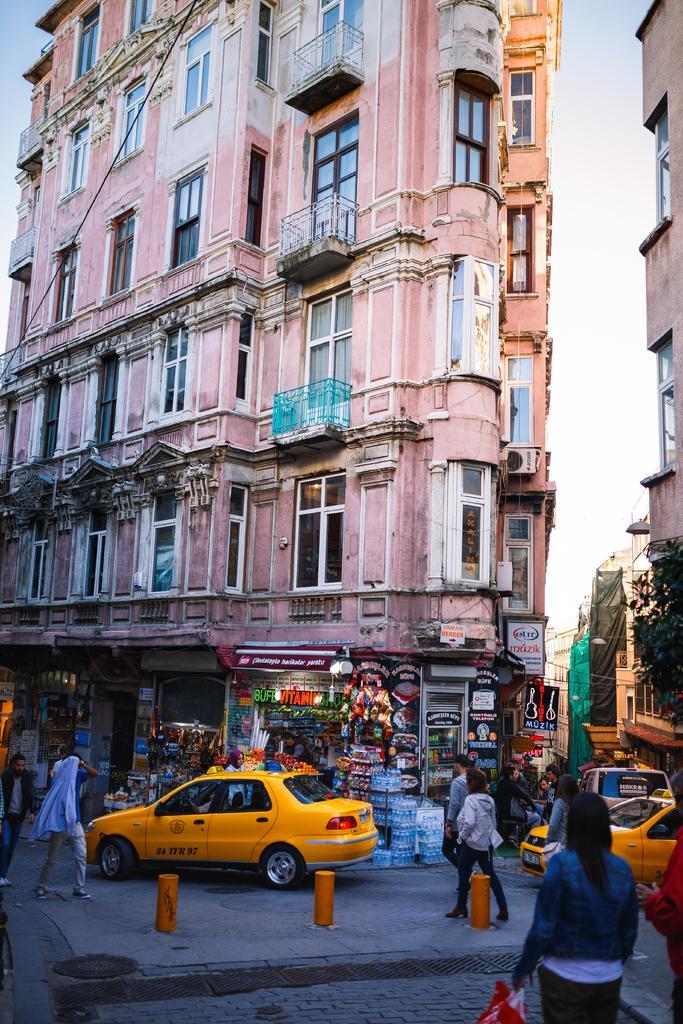How would you summarize this image in a sentence or two? In this image we can see buildings. On the right there is a tree. At the bottom we can see vehicles on the road and we can see people. There are stores. In the background there is sky. 